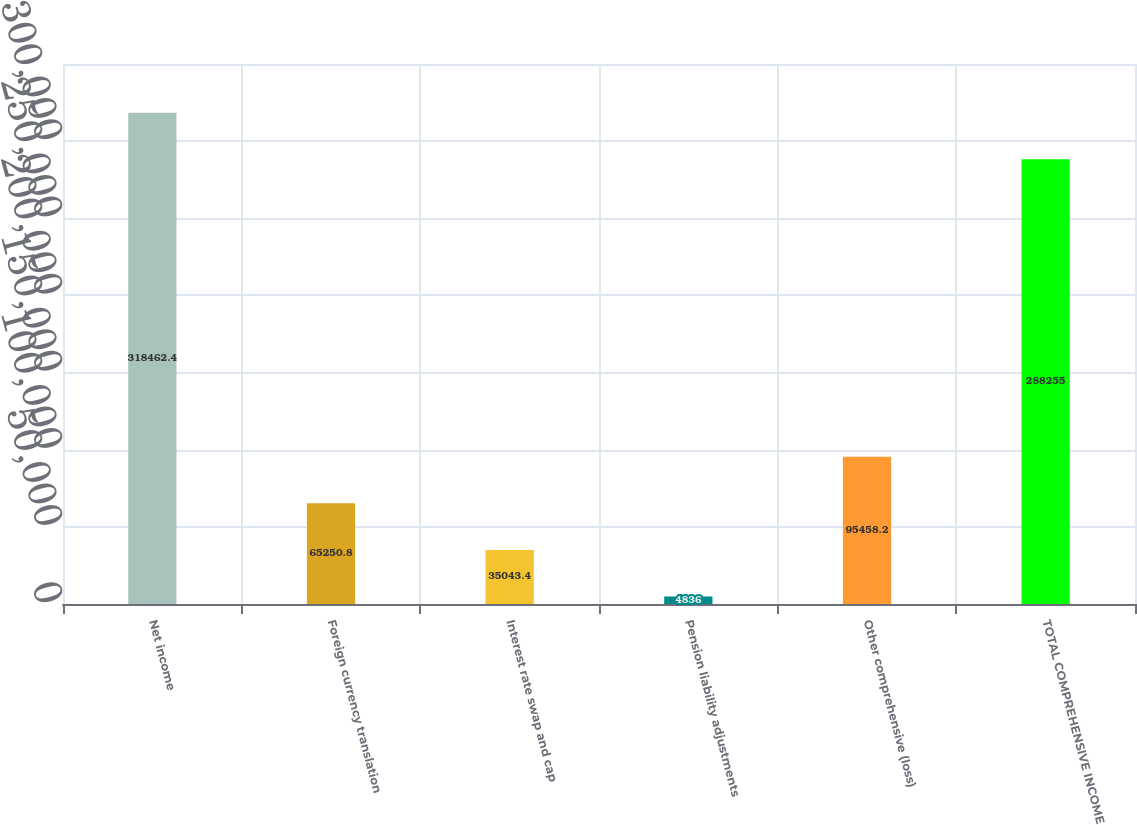<chart> <loc_0><loc_0><loc_500><loc_500><bar_chart><fcel>Net income<fcel>Foreign currency translation<fcel>Interest rate swap and cap<fcel>Pension liability adjustments<fcel>Other comprehensive (loss)<fcel>TOTAL COMPREHENSIVE INCOME<nl><fcel>318462<fcel>65250.8<fcel>35043.4<fcel>4836<fcel>95458.2<fcel>288255<nl></chart> 